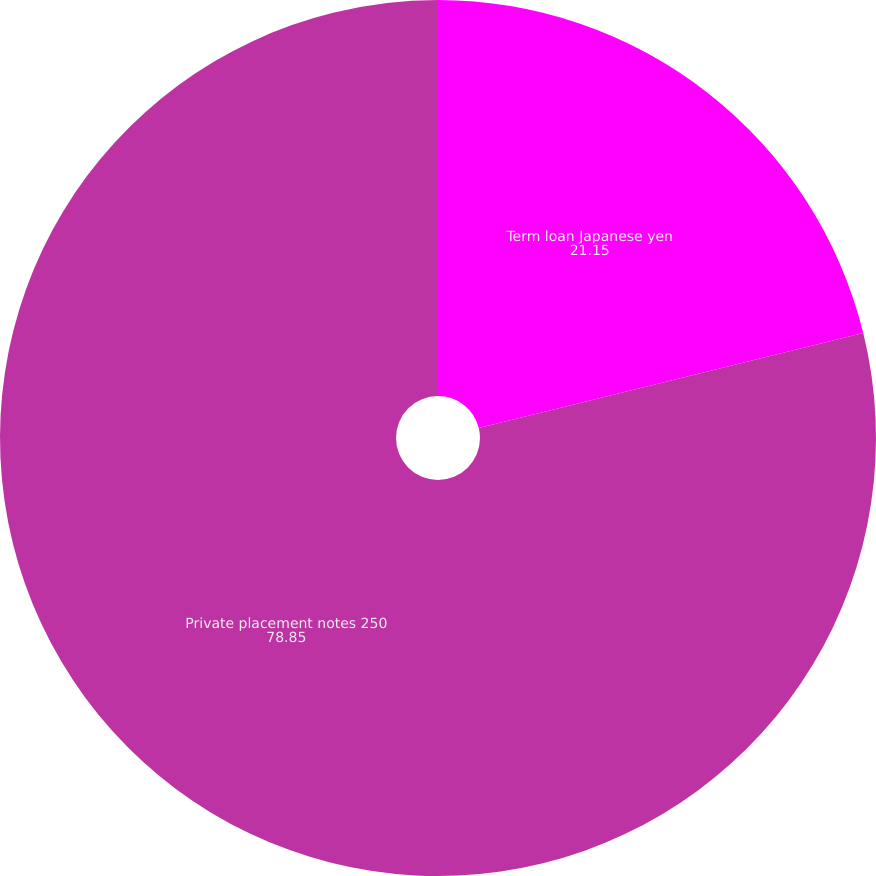Convert chart. <chart><loc_0><loc_0><loc_500><loc_500><pie_chart><fcel>Term loan Japanese yen<fcel>Private placement notes 250<nl><fcel>21.15%<fcel>78.85%<nl></chart> 